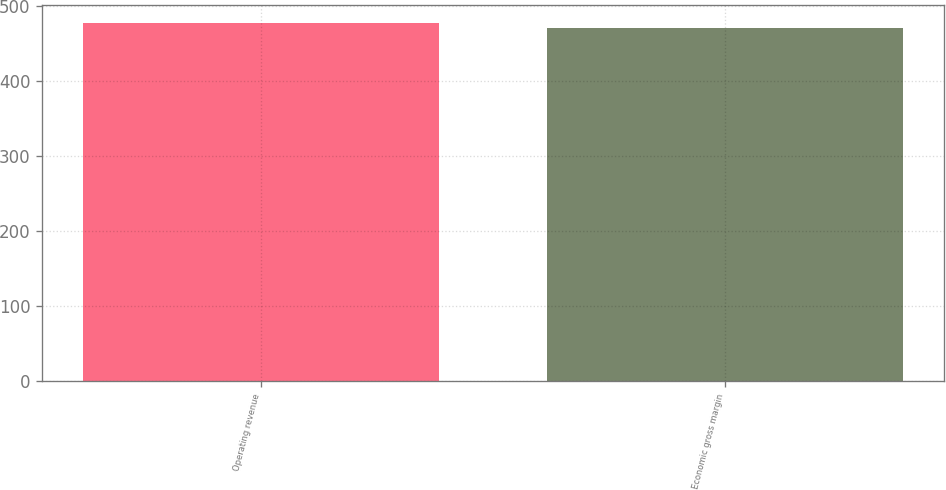Convert chart. <chart><loc_0><loc_0><loc_500><loc_500><bar_chart><fcel>Operating revenue<fcel>Economic gross margin<nl><fcel>478<fcel>471<nl></chart> 